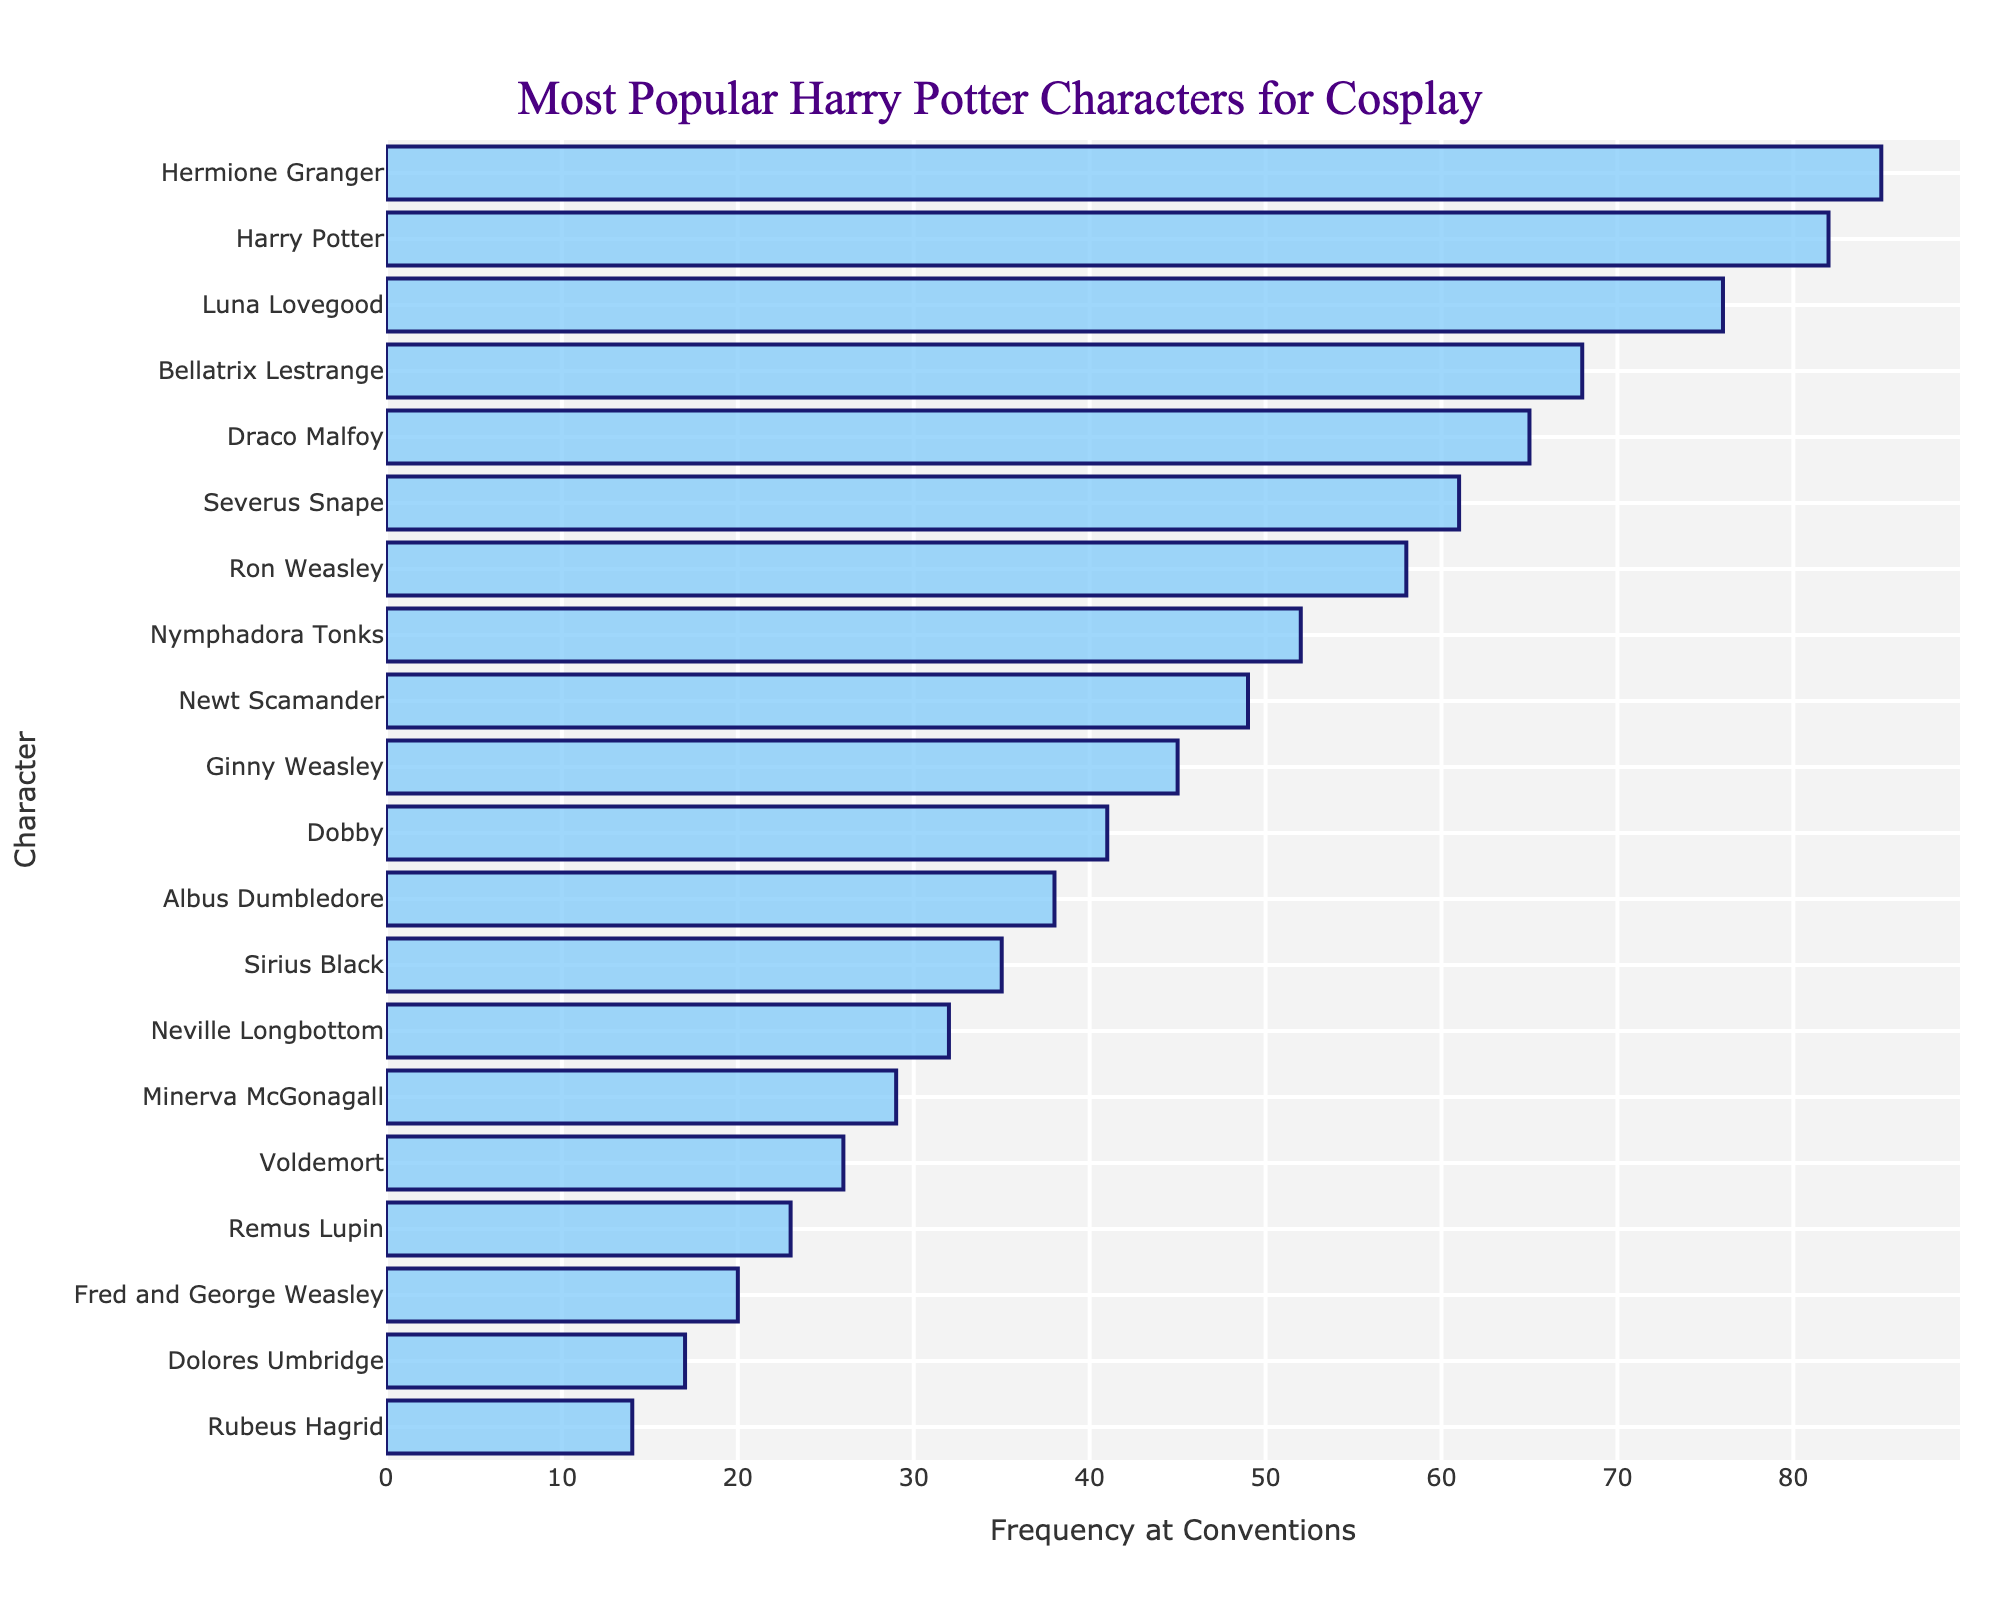Which character has the highest frequency for cosplay? The character with the highest bar length represents the highest frequency. Looking at the chart, the bar for Hermione Granger is the longest.
Answer: Hermione Granger Which two characters have the closest frequency counts? We need to compare the frequencies and find the two with the smallest absolute difference. Luna Lovegood has 76 and Bellatrix Lestrange has 68, which means the difference is 8. For Harry Potter and Hermione Granger, the difference is only 3 (85 - 82).
Answer: Hermione Granger and Harry Potter Which character has a frequency closer to 50, Newt Scamander or Nymphadora Tonks? Newt Scamander has a frequency of 49, and Nymphadora Tonks has a frequency of 52. We compare how close these are to 50:
Answer: Newt Scamander What is the combined frequency of Ron Weasley and Ginny Weasley? Adding Ron Weasley's frequency of 58 and Ginny Weasley's frequency of 45 gives us the combined frequency: 58 + 45 = 103
Answer: 103 How many characters have a frequency higher than 60? By counting the bars with frequency values higher than 60: Hermione Granger, Harry Potter, Luna Lovegood, Bellatrix Lestrange, Draco Malfoy, and Severus Snape.
Answer: 6 Which character has the lowest frequency for cosplay? The character with the smallest bar length has the lowest frequency. Rubeus Hagrid's bar is the shortest.
Answer: Rubeus Hagrid By how much does Hermione Granger's frequency exceed Harry Potter's? Subtract Harry Potter's frequency (82) from Hermione Granger's frequency (85): 85 - 82 = 3
Answer: 3 Is the frequency of Voldemort higher or lower than the frequency of Sirius Black? Comparing the lengths of the bars for Voldemort (26) and Sirius Black (35), Voldemort's is shorter.
Answer: Lower What is the average frequency of the top five most popular characters? The top five characters are Hermione Granger (85), Harry Potter (82), Luna Lovegood (76), Bellatrix Lestrange (68), and Draco Malfoy (65). Adding these: 85 + 82 + 76 + 68 + 65 = 376, then dividing by 5: 376 / 5 = 75.2
Answer: 75.2 What is the total frequency of all Weasley family members listed in the chart? The Weasley members are Ron Weasley (58), Ginny Weasley (45), Fred and George Weasley (20). Adding these: 58 + 45 + 20 = 123
Answer: 123 